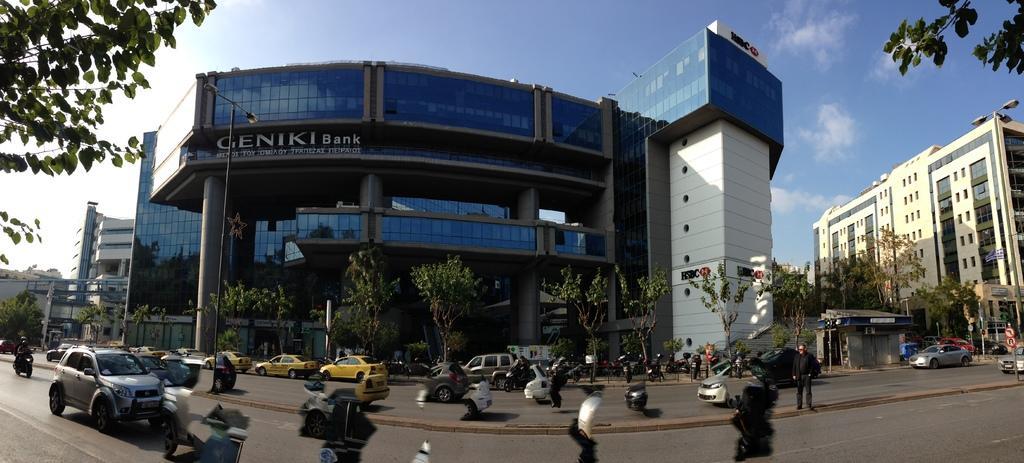Can you describe this image briefly? In this image we can see few vehicles on the road, a person standing on the divider, there is are street lights, a pole with sign boards, few trees, buildings, a building with text and the sky with clouds in the background. 